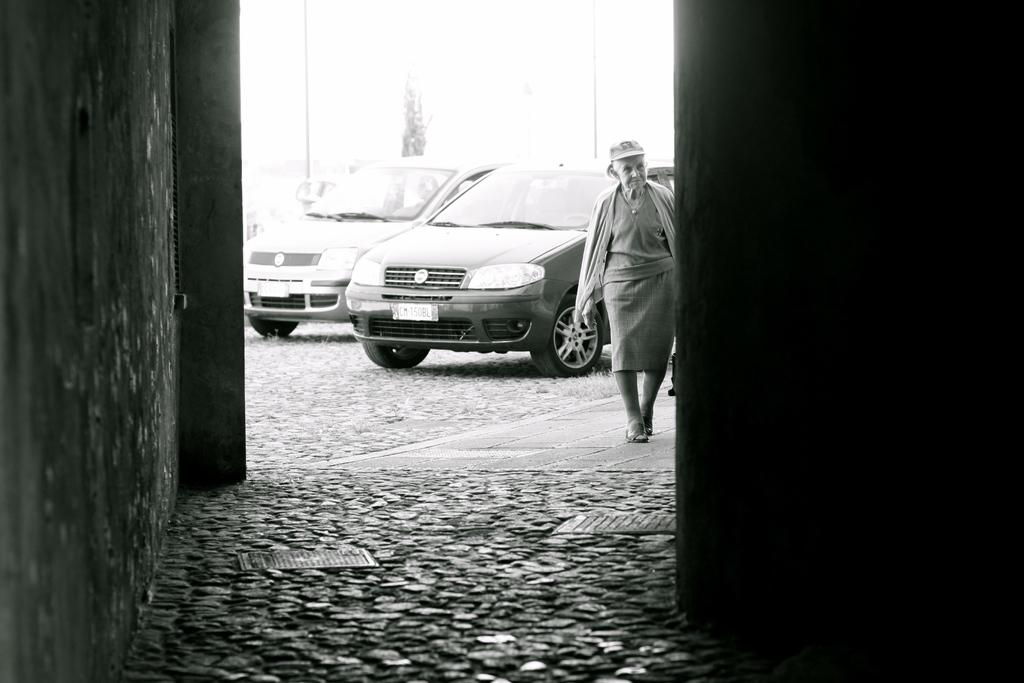What type of vehicles can be seen in the image? There are cars in the image. What is the old woman doing in the image? The old woman is walking in the image. What structure is present in the image? There is a wall in the image. What surface is visible beneath the cars and the old woman? The floor is visible in the image. What news is the old woman reading in the image? There is no news or any reading material visible in the image; the old woman is simply walking. How does the air affect the movement of the cars in the image? There is no information about the air or its effect on the cars in the image; we only know that the cars are present. 